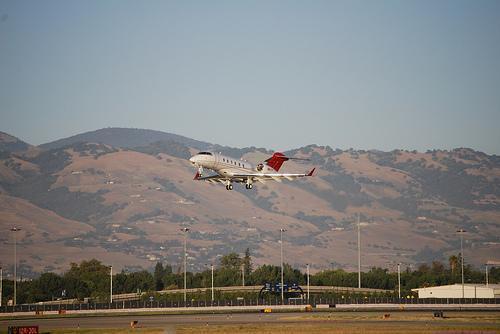How many planes are there?
Give a very brief answer. 1. 